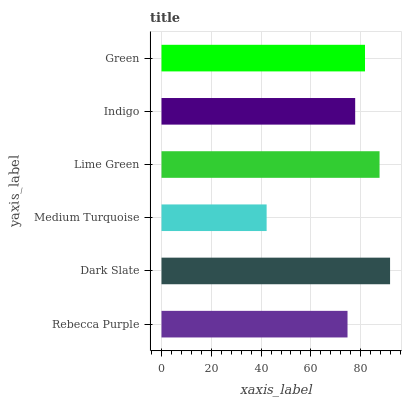Is Medium Turquoise the minimum?
Answer yes or no. Yes. Is Dark Slate the maximum?
Answer yes or no. Yes. Is Dark Slate the minimum?
Answer yes or no. No. Is Medium Turquoise the maximum?
Answer yes or no. No. Is Dark Slate greater than Medium Turquoise?
Answer yes or no. Yes. Is Medium Turquoise less than Dark Slate?
Answer yes or no. Yes. Is Medium Turquoise greater than Dark Slate?
Answer yes or no. No. Is Dark Slate less than Medium Turquoise?
Answer yes or no. No. Is Green the high median?
Answer yes or no. Yes. Is Indigo the low median?
Answer yes or no. Yes. Is Lime Green the high median?
Answer yes or no. No. Is Medium Turquoise the low median?
Answer yes or no. No. 